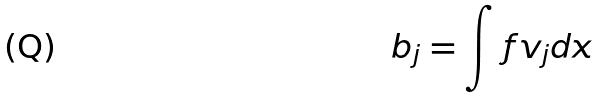Convert formula to latex. <formula><loc_0><loc_0><loc_500><loc_500>b _ { j } = \int f v _ { j } d x</formula> 